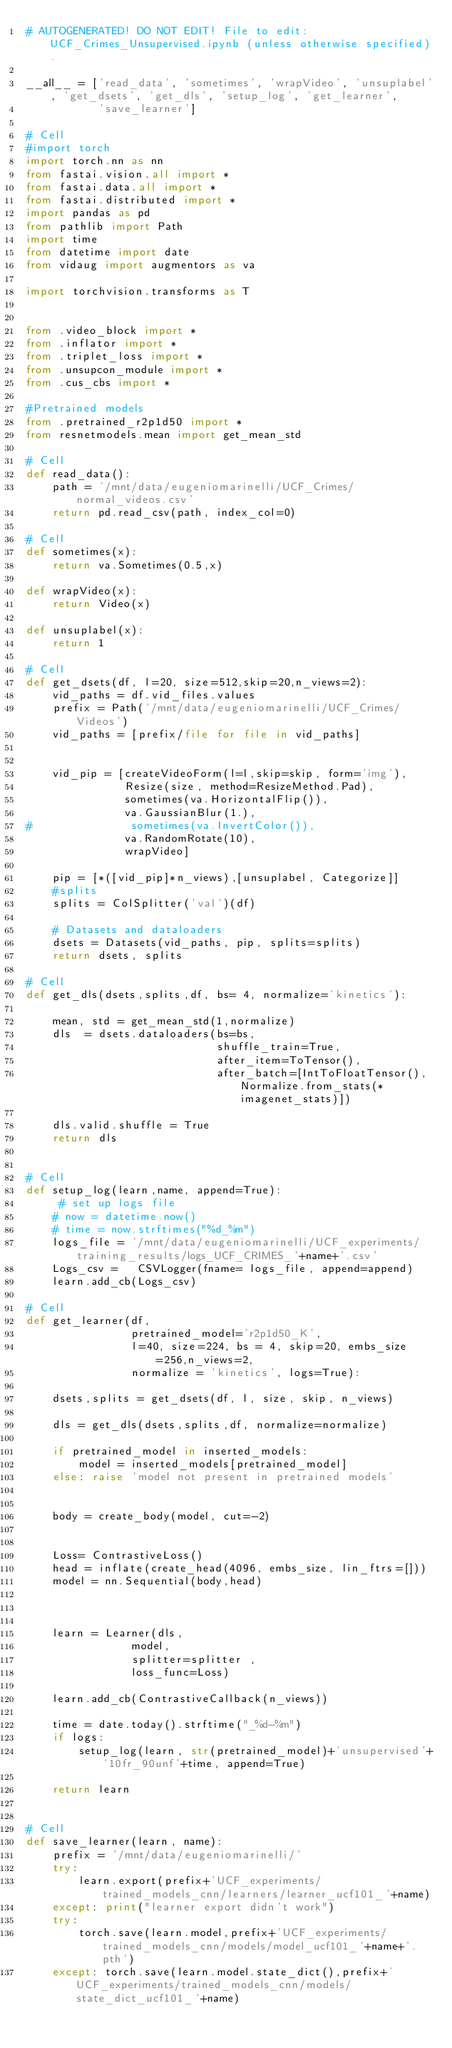Convert code to text. <code><loc_0><loc_0><loc_500><loc_500><_Python_># AUTOGENERATED! DO NOT EDIT! File to edit: UCF_Crimes_Unsupervised.ipynb (unless otherwise specified).

__all__ = ['read_data', 'sometimes', 'wrapVideo', 'unsuplabel', 'get_dsets', 'get_dls', 'setup_log', 'get_learner',
           'save_learner']

# Cell
#import torch
import torch.nn as nn
from fastai.vision.all import *
from fastai.data.all import *
from fastai.distributed import *
import pandas as pd
from pathlib import Path
import time
from datetime import date
from vidaug import augmentors as va

import torchvision.transforms as T


from .video_block import *
from .inflator import *
from .triplet_loss import *
from .unsupcon_module import *
from .cus_cbs import *

#Pretrained models
from .pretrained_r2p1d50 import *
from resnetmodels.mean import get_mean_std

# Cell
def read_data():
    path = '/mnt/data/eugeniomarinelli/UCF_Crimes/normal_videos.csv'
    return pd.read_csv(path, index_col=0)

# Cell
def sometimes(x):
    return va.Sometimes(0.5,x)

def wrapVideo(x):
    return Video(x)

def unsuplabel(x):
    return 1

# Cell
def get_dsets(df, l=20, size=512,skip=20,n_views=2):
    vid_paths = df.vid_files.values
    prefix = Path('/mnt/data/eugeniomarinelli/UCF_Crimes/Videos')
    vid_paths = [prefix/file for file in vid_paths]


    vid_pip = [createVideoForm(l=l,skip=skip, form='img'),
               Resize(size, method=ResizeMethod.Pad),
               sometimes(va.HorizontalFlip()),
               va.GaussianBlur(1.),
#               sometimes(va.InvertColor()),
               va.RandomRotate(10),
               wrapVideo]

    pip = [*([vid_pip]*n_views),[unsuplabel, Categorize]]
    #splits
    splits = ColSplitter('val')(df)

    # Datasets and dataloaders
    dsets = Datasets(vid_paths, pip, splits=splits)
    return dsets, splits

# Cell
def get_dls(dsets,splits,df, bs= 4, normalize='kinetics'):

    mean, std = get_mean_std(1,normalize)
    dls  = dsets.dataloaders(bs=bs,
                             shuffle_train=True,
                             after_item=ToTensor(),
                             after_batch=[IntToFloatTensor(), Normalize.from_stats(*imagenet_stats)])

    dls.valid.shuffle = True
    return dls


# Cell
def setup_log(learn,name, append=True):
     # set up logs file
    # now = datetime.now()
    # time = now.strftimes("%d_%m")
    logs_file = '/mnt/data/eugeniomarinelli/UCF_experiments/training_results/logs_UCF_CRIMES_'+name+'.csv'
    Logs_csv =   CSVLogger(fname= logs_file, append=append)
    learn.add_cb(Logs_csv)

# Cell
def get_learner(df,
                pretrained_model='r2p1d50_K',
                l=40, size=224, bs = 4, skip=20, embs_size=256,n_views=2,
                normalize = 'kinetics', logs=True):

    dsets,splits = get_dsets(df, l, size, skip, n_views)

    dls = get_dls(dsets,splits,df, normalize=normalize)

    if pretrained_model in inserted_models:
        model = inserted_models[pretrained_model]
    else: raise 'model not present in pretrained models'


    body = create_body(model, cut=-2)


    Loss= ContrastiveLoss()
    head = inflate(create_head(4096, embs_size, lin_ftrs=[]))
    model = nn.Sequential(body,head)



    learn = Learner(dls,
                model,
                splitter=splitter ,
                loss_func=Loss)

    learn.add_cb(ContrastiveCallback(n_views))

    time = date.today().strftime("_%d-%m")
    if logs:
        setup_log(learn, str(pretrained_model)+'unsupervised'+'10fr_90unf'+time, append=True)

    return learn


# Cell
def save_learner(learn, name):
    prefix = '/mnt/data/eugeniomarinelli/'
    try:
        learn.export(prefix+'UCF_experiments/trained_models_cnn/learners/learner_ucf101_'+name)
    except: print("learner export didn't work")
    try:
        torch.save(learn.model,prefix+'UCF_experiments/trained_models_cnn/models/model_ucf101_'+name+'.pth')
    except: torch.save(learn.model.state_dict(),prefix+'UCF_experiments/trained_models_cnn/models/state_dict_ucf101_'+name)

</code> 